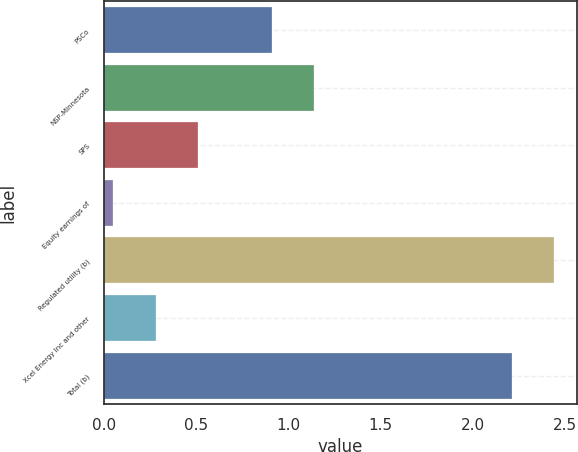Convert chart. <chart><loc_0><loc_0><loc_500><loc_500><bar_chart><fcel>PSCo<fcel>NSP-Minnesota<fcel>SPS<fcel>Equity earnings of<fcel>Regulated utility (b)<fcel>Xcel Energy Inc and other<fcel>Total (b)<nl><fcel>0.91<fcel>1.14<fcel>0.51<fcel>0.05<fcel>2.44<fcel>0.28<fcel>2.21<nl></chart> 